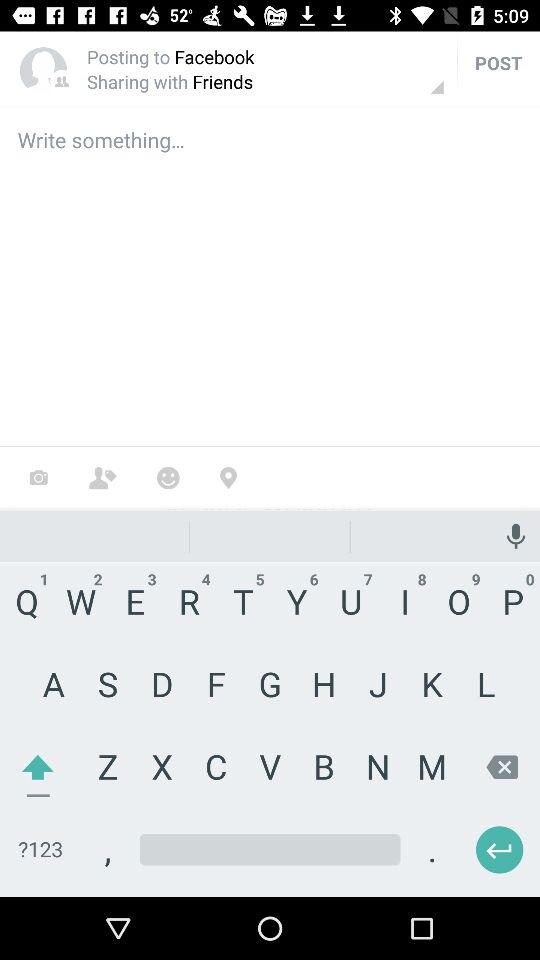What application is asking for permission? The application asking for permission is "Sworkit". 